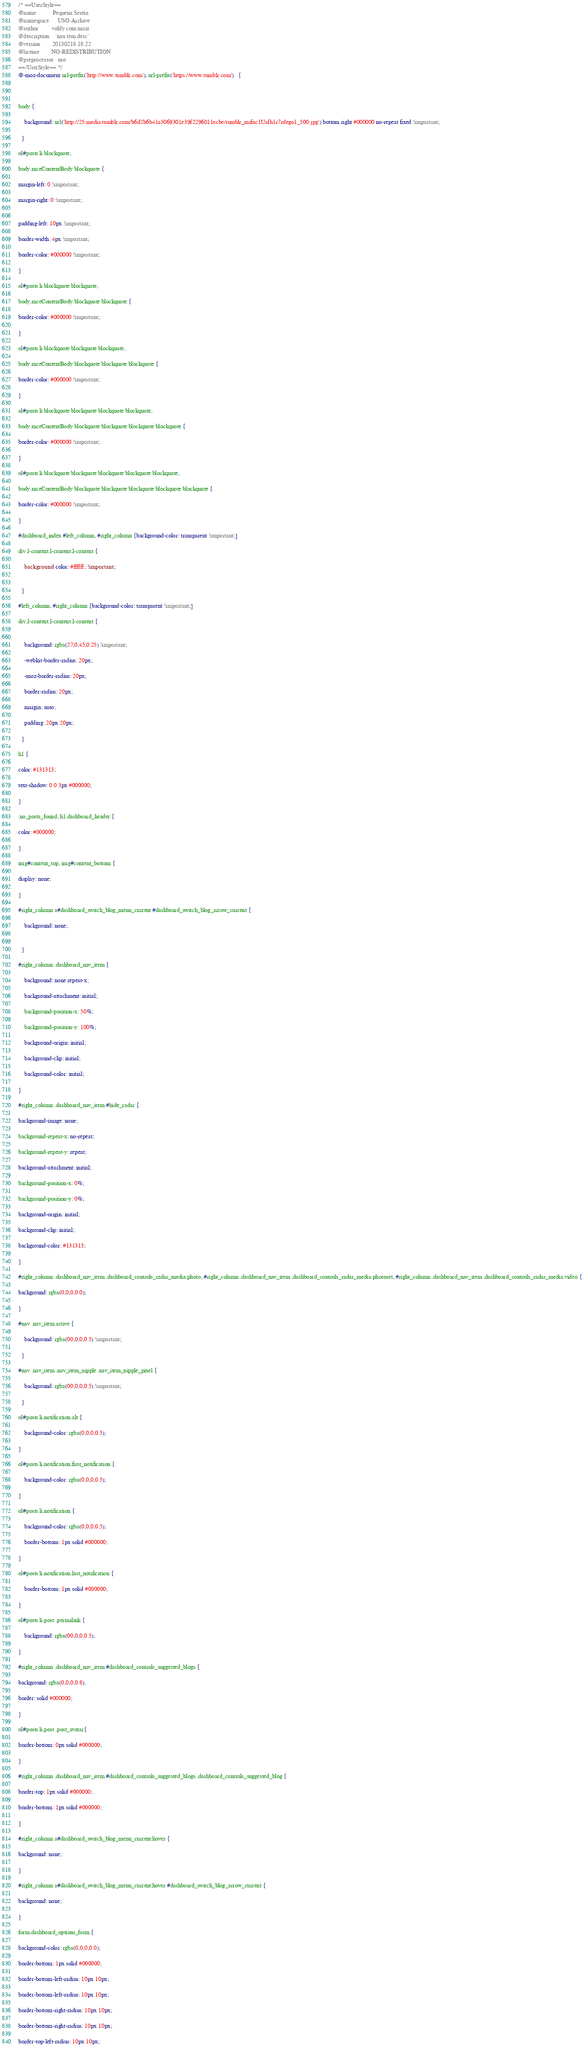<code> <loc_0><loc_0><loc_500><loc_500><_CSS_>/* ==UserStyle==
@name           Pequena Sereia
@namespace      USO Archive
@author         voldy com nariz
@description    `nau tem desc`
@version        20130218.18.22
@license        NO-REDISTRIBUTION
@preprocessor   uso
==/UserStyle== */
@-moz-document url-prefix('http://www.tumblr.com'), url-prefix('https://www.tumblr.com')   {



body {

    background: url('http://25.media.tumblr.com/b6d2b6b41a5069301e39f2296011ecbe/tumblr_mifxc1Uafh1r7rdego1_500.jpg') bottom right #000000 no-repeat fixed !important;

  }

ol#posts li blockquote,

body.mceContentBody blockquote {

margin-left: 0 !important;

margin-right: 0 !important;


padding-left: 10px !important;

border-width: 4px !important;

border-color: #000000 !important;

}

ol#posts li blockquote blockquote,

body.mceContentBody blockquote blockquote {

border-color: #000000 !important;

}

ol#posts li blockquote blockquote blockquote,

body.mceContentBody blockquote blockquote blockquote {

border-color: #000000 !important;

}

ol#posts li blockquote blockquote blockquote blockquote,

body.mceContentBody blockquote blockquote blockquote blockquote {

border-color: #000000 !important;

}

ol#posts li blockquote blockquote blockquote blockquote blockquote,

body.mceContentBody blockquote blockquote blockquote blockquote blockquote {

border-color: #000000 !important;

}

#dashboard_index #left_column, #right_column {background-color: transparent !important;}

div.l-content.l-content.l-content {

    background color: #ffffff; !important;


  }

#left_column, #right_column {background-color: transparent !important;}

div.l-content.l-content.l-content {


    background: rgba(27,0,45,0.25) !important;

    -webkit-border-radius: 20px;

    -moz-border-radius: 20px;

    border-radius: 20px;

    margin: auto;

    padding: 20px 20px;

  }

h1 {

color: #131313;

text-shadow: 0 0 3px #000000;

}

.no_posts_found, h1.dashboard_header {

color: #000000;

}

img#content_top, img#content_bottom {

display: none;

}

#right_column a#dashboard_switch_blog_menu_current #dashboard_switch_blog_arrow_current {

    background: none;


  }

#right_column .dashboard_nav_item {

    background: none repeat-x;

    background-attachment: initial;

    background-position-x: 50%;

    background-position-y: 100%;

    background-origin: initial;

    background-clip: initial;

    background-color: initial;

}

#right_column .dashboard_nav_item #hide_radar {

background-image: none;

background-repeat-x: no-repeat;

background-repeat-y: repeat;

background-attachment: initial;

background-position-x: 0%;

background-position-y: 0%;

background-origin: initial;

background-clip: initial;

background-color: #131313;

}

#right_column .dashboard_nav_item .dashboard_controls_radar_media.photo, #right_column .dashboard_nav_item .dashboard_controls_radar_media.photoset, #right_column .dashboard_nav_item .dashboard_controls_radar_media.video {

background: rgba(0,0,0,0.0);

}

#nav .nav_item.active {

    background: rgba(00,0,0,0.5) !important;

  }

#nav .nav_item .nav_item_nipple .nav_item_nipple_pixel {

    background: rgba(00,0,0,0.5) !important;

  }

ol#posts li.notification.alt {

    background-color: rgba(0,0,0,0.5);

}

ol#posts li.notification.first_notification {

    background-color: rgba(0,0,0,0.5);

}

ol#posts li.notification {

    background-color: rgba(0,0,0,0.5);

    border-bottom: 1px solid #000000;

}

ol#posts li.notification.last_notification {

    border-bottom: 1px solid #000000;

}

ol#posts li.post .permalink {

    background: rgba(00,0,0,0.5);

}

#right_column .dashboard_nav_item #dashboard_controls_suggested_blogs {

background: rgba(0,0,0,0.8);

border: solid #000000;

}

ol#posts li.post .post_avatar{

border-bottom: 0px solid #000000;

}

#right_column .dashboard_nav_item #dashboard_controls_suggested_blogs .dashboard_controls_suggested_blog {

border-top: 1px solid #000000;

border-bottom: 1px solid #000000;

}

#right_column a#dashboard_switch_blog_menu_current:hover {

background: none;

}

#right_column a#dashboard_switch_blog_menu_current:hover #dashboard_switch_blog_arrow_current {

background: none;

}

form.dashboard_options_form {

background-color: rgba(0,0,0,0.0);

border-bottom: 1px solid #000000;

border-bottom-left-radius: 10px 10px;

border-bottom-left-radius: 10px 10px;

border-bottom-right-radius: 10px 10px;

border-bottom-right-radius: 10px 10px;

border-top-left-radius: 10px 10px;
</code> 